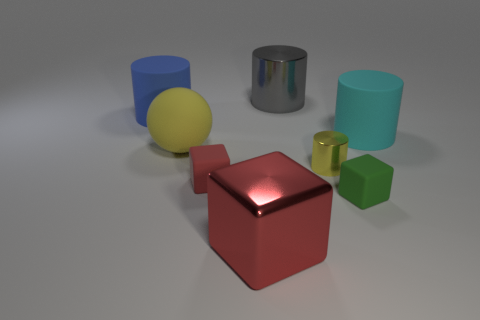Subtract all shiny blocks. How many blocks are left? 2 Subtract all green blocks. How many blocks are left? 2 Add 1 small brown balls. How many objects exist? 9 Subtract 0 yellow blocks. How many objects are left? 8 Subtract all cubes. How many objects are left? 5 Subtract 1 blocks. How many blocks are left? 2 Subtract all blue spheres. Subtract all blue cubes. How many spheres are left? 1 Subtract all purple blocks. How many yellow cylinders are left? 1 Subtract all large yellow matte things. Subtract all large blue things. How many objects are left? 6 Add 2 green matte cubes. How many green matte cubes are left? 3 